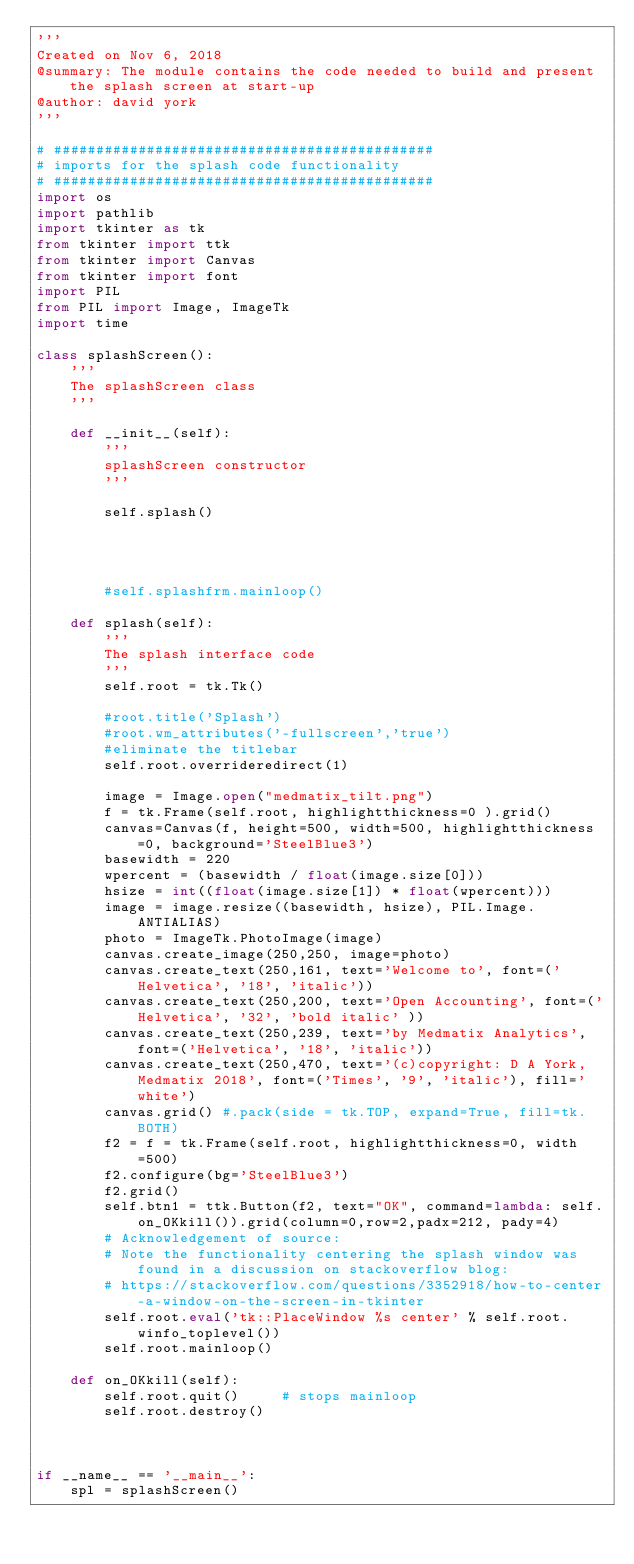<code> <loc_0><loc_0><loc_500><loc_500><_Python_>'''
Created on Nov 6, 2018
@summary: The module contains the code needed to build and present the splash screen at start-up
@author: david york
'''

# #############################################
# imports for the splash code functionality
# #############################################
import os
import pathlib
import tkinter as tk
from tkinter import ttk
from tkinter import Canvas
from tkinter import font
import PIL
from PIL import Image, ImageTk
import time

class splashScreen():
    '''
    The splashScreen class
    '''
     
    def __init__(self):
        '''
        splashScreen constructor
        '''
        
        self.splash()        
        
        
        
        
        #self.splashfrm.mainloop()
     
    def splash(self):
        '''
        The splash interface code
        '''
        self.root = tk.Tk()
        
        #root.title('Splash')
        #root.wm_attributes('-fullscreen','true')
        #eliminate the titlebar
        self.root.overrideredirect(1)
        
        image = Image.open("medmatix_tilt.png")
        f = tk.Frame(self.root, highlightthickness=0 ).grid()
        canvas=Canvas(f, height=500, width=500, highlightthickness=0, background='SteelBlue3')
        basewidth = 220
        wpercent = (basewidth / float(image.size[0]))
        hsize = int((float(image.size[1]) * float(wpercent)))
        image = image.resize((basewidth, hsize), PIL.Image.ANTIALIAS)
        photo = ImageTk.PhotoImage(image)
        canvas.create_image(250,250, image=photo)
        canvas.create_text(250,161, text='Welcome to', font=('Helvetica', '18', 'italic'))
        canvas.create_text(250,200, text='Open Accounting', font=('Helvetica', '32', 'bold italic' ))
        canvas.create_text(250,239, text='by Medmatix Analytics', font=('Helvetica', '18', 'italic'))
        canvas.create_text(250,470, text='(c)copyright: D A York, Medmatix 2018', font=('Times', '9', 'italic'), fill='white')         
        canvas.grid() #.pack(side = tk.TOP, expand=True, fill=tk.BOTH)
        f2 = f = tk.Frame(self.root, highlightthickness=0, width=500)
        f2.configure(bg='SteelBlue3')
        f2.grid()
        self.btn1 = ttk.Button(f2, text="OK", command=lambda: self.on_OKkill()).grid(column=0,row=2,padx=212, pady=4)
        # Acknowledgement of source:
        # Note the functionality centering the splash window was found in a discussion on stackoverflow blog:
        # https://stackoverflow.com/questions/3352918/how-to-center-a-window-on-the-screen-in-tkinter
        self.root.eval('tk::PlaceWindow %s center' % self.root.winfo_toplevel())
        self.root.mainloop()
        
    def on_OKkill(self):
        self.root.quit()     # stops mainloop
        self.root.destroy()
        
        
        
if __name__ == '__main__':
    spl = splashScreen()</code> 